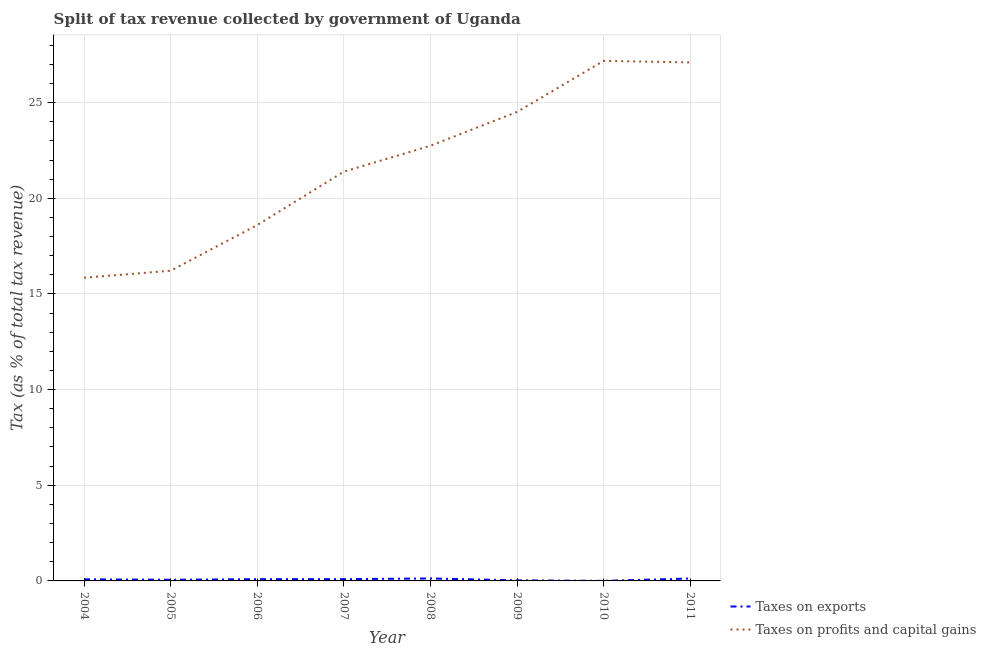How many different coloured lines are there?
Your answer should be very brief. 2. Is the number of lines equal to the number of legend labels?
Offer a very short reply. Yes. What is the percentage of revenue obtained from taxes on profits and capital gains in 2004?
Ensure brevity in your answer.  15.85. Across all years, what is the maximum percentage of revenue obtained from taxes on profits and capital gains?
Offer a terse response. 27.18. Across all years, what is the minimum percentage of revenue obtained from taxes on profits and capital gains?
Provide a short and direct response. 15.85. In which year was the percentage of revenue obtained from taxes on profits and capital gains minimum?
Offer a terse response. 2004. What is the total percentage of revenue obtained from taxes on exports in the graph?
Offer a very short reply. 0.62. What is the difference between the percentage of revenue obtained from taxes on exports in 2009 and that in 2011?
Your answer should be very brief. -0.09. What is the difference between the percentage of revenue obtained from taxes on profits and capital gains in 2008 and the percentage of revenue obtained from taxes on exports in 2007?
Ensure brevity in your answer.  22.65. What is the average percentage of revenue obtained from taxes on exports per year?
Your answer should be very brief. 0.08. In the year 2009, what is the difference between the percentage of revenue obtained from taxes on profits and capital gains and percentage of revenue obtained from taxes on exports?
Make the answer very short. 24.48. What is the ratio of the percentage of revenue obtained from taxes on profits and capital gains in 2004 to that in 2006?
Your response must be concise. 0.85. Is the percentage of revenue obtained from taxes on exports in 2008 less than that in 2010?
Make the answer very short. No. Is the difference between the percentage of revenue obtained from taxes on exports in 2006 and 2008 greater than the difference between the percentage of revenue obtained from taxes on profits and capital gains in 2006 and 2008?
Provide a short and direct response. Yes. What is the difference between the highest and the second highest percentage of revenue obtained from taxes on exports?
Your answer should be very brief. 0. What is the difference between the highest and the lowest percentage of revenue obtained from taxes on profits and capital gains?
Your response must be concise. 11.33. Is the sum of the percentage of revenue obtained from taxes on exports in 2005 and 2010 greater than the maximum percentage of revenue obtained from taxes on profits and capital gains across all years?
Your answer should be very brief. No. Is the percentage of revenue obtained from taxes on profits and capital gains strictly greater than the percentage of revenue obtained from taxes on exports over the years?
Provide a short and direct response. Yes. Is the percentage of revenue obtained from taxes on profits and capital gains strictly less than the percentage of revenue obtained from taxes on exports over the years?
Give a very brief answer. No. How many lines are there?
Provide a succinct answer. 2. Does the graph contain grids?
Your answer should be very brief. Yes. Where does the legend appear in the graph?
Keep it short and to the point. Bottom right. What is the title of the graph?
Ensure brevity in your answer.  Split of tax revenue collected by government of Uganda. Does "From production" appear as one of the legend labels in the graph?
Ensure brevity in your answer.  No. What is the label or title of the X-axis?
Your response must be concise. Year. What is the label or title of the Y-axis?
Offer a terse response. Tax (as % of total tax revenue). What is the Tax (as % of total tax revenue) of Taxes on exports in 2004?
Give a very brief answer. 0.08. What is the Tax (as % of total tax revenue) of Taxes on profits and capital gains in 2004?
Your answer should be compact. 15.85. What is the Tax (as % of total tax revenue) in Taxes on exports in 2005?
Ensure brevity in your answer.  0.06. What is the Tax (as % of total tax revenue) in Taxes on profits and capital gains in 2005?
Provide a succinct answer. 16.21. What is the Tax (as % of total tax revenue) of Taxes on exports in 2006?
Ensure brevity in your answer.  0.09. What is the Tax (as % of total tax revenue) in Taxes on profits and capital gains in 2006?
Ensure brevity in your answer.  18.6. What is the Tax (as % of total tax revenue) in Taxes on exports in 2007?
Your answer should be very brief. 0.09. What is the Tax (as % of total tax revenue) of Taxes on profits and capital gains in 2007?
Ensure brevity in your answer.  21.39. What is the Tax (as % of total tax revenue) in Taxes on exports in 2008?
Offer a very short reply. 0.13. What is the Tax (as % of total tax revenue) of Taxes on profits and capital gains in 2008?
Offer a very short reply. 22.74. What is the Tax (as % of total tax revenue) in Taxes on exports in 2009?
Your answer should be very brief. 0.03. What is the Tax (as % of total tax revenue) of Taxes on profits and capital gains in 2009?
Ensure brevity in your answer.  24.51. What is the Tax (as % of total tax revenue) of Taxes on exports in 2010?
Give a very brief answer. 0. What is the Tax (as % of total tax revenue) of Taxes on profits and capital gains in 2010?
Keep it short and to the point. 27.18. What is the Tax (as % of total tax revenue) of Taxes on exports in 2011?
Give a very brief answer. 0.13. What is the Tax (as % of total tax revenue) in Taxes on profits and capital gains in 2011?
Provide a short and direct response. 27.1. Across all years, what is the maximum Tax (as % of total tax revenue) in Taxes on exports?
Your answer should be compact. 0.13. Across all years, what is the maximum Tax (as % of total tax revenue) in Taxes on profits and capital gains?
Give a very brief answer. 27.18. Across all years, what is the minimum Tax (as % of total tax revenue) of Taxes on exports?
Provide a succinct answer. 0. Across all years, what is the minimum Tax (as % of total tax revenue) in Taxes on profits and capital gains?
Make the answer very short. 15.85. What is the total Tax (as % of total tax revenue) of Taxes on exports in the graph?
Provide a short and direct response. 0.62. What is the total Tax (as % of total tax revenue) in Taxes on profits and capital gains in the graph?
Your response must be concise. 173.59. What is the difference between the Tax (as % of total tax revenue) in Taxes on exports in 2004 and that in 2005?
Provide a short and direct response. 0.02. What is the difference between the Tax (as % of total tax revenue) in Taxes on profits and capital gains in 2004 and that in 2005?
Offer a very short reply. -0.36. What is the difference between the Tax (as % of total tax revenue) in Taxes on exports in 2004 and that in 2006?
Offer a terse response. -0.01. What is the difference between the Tax (as % of total tax revenue) of Taxes on profits and capital gains in 2004 and that in 2006?
Provide a succinct answer. -2.75. What is the difference between the Tax (as % of total tax revenue) in Taxes on exports in 2004 and that in 2007?
Your answer should be very brief. -0.01. What is the difference between the Tax (as % of total tax revenue) in Taxes on profits and capital gains in 2004 and that in 2007?
Provide a succinct answer. -5.54. What is the difference between the Tax (as % of total tax revenue) in Taxes on exports in 2004 and that in 2008?
Offer a terse response. -0.04. What is the difference between the Tax (as % of total tax revenue) of Taxes on profits and capital gains in 2004 and that in 2008?
Provide a short and direct response. -6.9. What is the difference between the Tax (as % of total tax revenue) of Taxes on exports in 2004 and that in 2009?
Make the answer very short. 0.05. What is the difference between the Tax (as % of total tax revenue) in Taxes on profits and capital gains in 2004 and that in 2009?
Provide a succinct answer. -8.66. What is the difference between the Tax (as % of total tax revenue) in Taxes on exports in 2004 and that in 2010?
Provide a short and direct response. 0.08. What is the difference between the Tax (as % of total tax revenue) in Taxes on profits and capital gains in 2004 and that in 2010?
Provide a short and direct response. -11.33. What is the difference between the Tax (as % of total tax revenue) of Taxes on exports in 2004 and that in 2011?
Provide a short and direct response. -0.04. What is the difference between the Tax (as % of total tax revenue) of Taxes on profits and capital gains in 2004 and that in 2011?
Provide a succinct answer. -11.25. What is the difference between the Tax (as % of total tax revenue) of Taxes on exports in 2005 and that in 2006?
Your answer should be compact. -0.03. What is the difference between the Tax (as % of total tax revenue) of Taxes on profits and capital gains in 2005 and that in 2006?
Your response must be concise. -2.39. What is the difference between the Tax (as % of total tax revenue) in Taxes on exports in 2005 and that in 2007?
Provide a succinct answer. -0.03. What is the difference between the Tax (as % of total tax revenue) of Taxes on profits and capital gains in 2005 and that in 2007?
Your answer should be very brief. -5.18. What is the difference between the Tax (as % of total tax revenue) in Taxes on exports in 2005 and that in 2008?
Keep it short and to the point. -0.07. What is the difference between the Tax (as % of total tax revenue) of Taxes on profits and capital gains in 2005 and that in 2008?
Give a very brief answer. -6.53. What is the difference between the Tax (as % of total tax revenue) in Taxes on exports in 2005 and that in 2009?
Ensure brevity in your answer.  0.03. What is the difference between the Tax (as % of total tax revenue) in Taxes on profits and capital gains in 2005 and that in 2009?
Your response must be concise. -8.3. What is the difference between the Tax (as % of total tax revenue) in Taxes on exports in 2005 and that in 2010?
Offer a terse response. 0.06. What is the difference between the Tax (as % of total tax revenue) of Taxes on profits and capital gains in 2005 and that in 2010?
Your answer should be very brief. -10.97. What is the difference between the Tax (as % of total tax revenue) in Taxes on exports in 2005 and that in 2011?
Your answer should be compact. -0.07. What is the difference between the Tax (as % of total tax revenue) of Taxes on profits and capital gains in 2005 and that in 2011?
Your answer should be very brief. -10.89. What is the difference between the Tax (as % of total tax revenue) of Taxes on exports in 2006 and that in 2007?
Offer a terse response. -0. What is the difference between the Tax (as % of total tax revenue) in Taxes on profits and capital gains in 2006 and that in 2007?
Ensure brevity in your answer.  -2.79. What is the difference between the Tax (as % of total tax revenue) in Taxes on exports in 2006 and that in 2008?
Offer a very short reply. -0.04. What is the difference between the Tax (as % of total tax revenue) of Taxes on profits and capital gains in 2006 and that in 2008?
Provide a short and direct response. -4.14. What is the difference between the Tax (as % of total tax revenue) in Taxes on exports in 2006 and that in 2009?
Your answer should be very brief. 0.06. What is the difference between the Tax (as % of total tax revenue) of Taxes on profits and capital gains in 2006 and that in 2009?
Keep it short and to the point. -5.91. What is the difference between the Tax (as % of total tax revenue) of Taxes on exports in 2006 and that in 2010?
Your answer should be compact. 0.09. What is the difference between the Tax (as % of total tax revenue) of Taxes on profits and capital gains in 2006 and that in 2010?
Offer a terse response. -8.58. What is the difference between the Tax (as % of total tax revenue) of Taxes on exports in 2006 and that in 2011?
Offer a very short reply. -0.03. What is the difference between the Tax (as % of total tax revenue) in Taxes on profits and capital gains in 2006 and that in 2011?
Provide a succinct answer. -8.5. What is the difference between the Tax (as % of total tax revenue) of Taxes on exports in 2007 and that in 2008?
Your answer should be compact. -0.04. What is the difference between the Tax (as % of total tax revenue) in Taxes on profits and capital gains in 2007 and that in 2008?
Offer a terse response. -1.35. What is the difference between the Tax (as % of total tax revenue) of Taxes on exports in 2007 and that in 2009?
Give a very brief answer. 0.06. What is the difference between the Tax (as % of total tax revenue) of Taxes on profits and capital gains in 2007 and that in 2009?
Your answer should be very brief. -3.12. What is the difference between the Tax (as % of total tax revenue) in Taxes on exports in 2007 and that in 2010?
Your response must be concise. 0.09. What is the difference between the Tax (as % of total tax revenue) in Taxes on profits and capital gains in 2007 and that in 2010?
Make the answer very short. -5.79. What is the difference between the Tax (as % of total tax revenue) of Taxes on exports in 2007 and that in 2011?
Provide a short and direct response. -0.03. What is the difference between the Tax (as % of total tax revenue) of Taxes on profits and capital gains in 2007 and that in 2011?
Your answer should be compact. -5.71. What is the difference between the Tax (as % of total tax revenue) in Taxes on exports in 2008 and that in 2009?
Keep it short and to the point. 0.1. What is the difference between the Tax (as % of total tax revenue) in Taxes on profits and capital gains in 2008 and that in 2009?
Make the answer very short. -1.77. What is the difference between the Tax (as % of total tax revenue) of Taxes on exports in 2008 and that in 2010?
Keep it short and to the point. 0.13. What is the difference between the Tax (as % of total tax revenue) in Taxes on profits and capital gains in 2008 and that in 2010?
Make the answer very short. -4.44. What is the difference between the Tax (as % of total tax revenue) of Taxes on exports in 2008 and that in 2011?
Offer a terse response. 0. What is the difference between the Tax (as % of total tax revenue) of Taxes on profits and capital gains in 2008 and that in 2011?
Offer a very short reply. -4.36. What is the difference between the Tax (as % of total tax revenue) of Taxes on exports in 2009 and that in 2010?
Make the answer very short. 0.03. What is the difference between the Tax (as % of total tax revenue) in Taxes on profits and capital gains in 2009 and that in 2010?
Make the answer very short. -2.67. What is the difference between the Tax (as % of total tax revenue) of Taxes on exports in 2009 and that in 2011?
Offer a terse response. -0.09. What is the difference between the Tax (as % of total tax revenue) of Taxes on profits and capital gains in 2009 and that in 2011?
Give a very brief answer. -2.59. What is the difference between the Tax (as % of total tax revenue) in Taxes on exports in 2010 and that in 2011?
Provide a succinct answer. -0.12. What is the difference between the Tax (as % of total tax revenue) of Taxes on profits and capital gains in 2010 and that in 2011?
Give a very brief answer. 0.08. What is the difference between the Tax (as % of total tax revenue) in Taxes on exports in 2004 and the Tax (as % of total tax revenue) in Taxes on profits and capital gains in 2005?
Your answer should be very brief. -16.13. What is the difference between the Tax (as % of total tax revenue) of Taxes on exports in 2004 and the Tax (as % of total tax revenue) of Taxes on profits and capital gains in 2006?
Your response must be concise. -18.52. What is the difference between the Tax (as % of total tax revenue) of Taxes on exports in 2004 and the Tax (as % of total tax revenue) of Taxes on profits and capital gains in 2007?
Give a very brief answer. -21.31. What is the difference between the Tax (as % of total tax revenue) in Taxes on exports in 2004 and the Tax (as % of total tax revenue) in Taxes on profits and capital gains in 2008?
Make the answer very short. -22.66. What is the difference between the Tax (as % of total tax revenue) of Taxes on exports in 2004 and the Tax (as % of total tax revenue) of Taxes on profits and capital gains in 2009?
Provide a succinct answer. -24.43. What is the difference between the Tax (as % of total tax revenue) in Taxes on exports in 2004 and the Tax (as % of total tax revenue) in Taxes on profits and capital gains in 2010?
Provide a succinct answer. -27.1. What is the difference between the Tax (as % of total tax revenue) of Taxes on exports in 2004 and the Tax (as % of total tax revenue) of Taxes on profits and capital gains in 2011?
Offer a terse response. -27.02. What is the difference between the Tax (as % of total tax revenue) of Taxes on exports in 2005 and the Tax (as % of total tax revenue) of Taxes on profits and capital gains in 2006?
Your answer should be very brief. -18.54. What is the difference between the Tax (as % of total tax revenue) in Taxes on exports in 2005 and the Tax (as % of total tax revenue) in Taxes on profits and capital gains in 2007?
Your answer should be compact. -21.33. What is the difference between the Tax (as % of total tax revenue) in Taxes on exports in 2005 and the Tax (as % of total tax revenue) in Taxes on profits and capital gains in 2008?
Provide a succinct answer. -22.68. What is the difference between the Tax (as % of total tax revenue) in Taxes on exports in 2005 and the Tax (as % of total tax revenue) in Taxes on profits and capital gains in 2009?
Your answer should be compact. -24.45. What is the difference between the Tax (as % of total tax revenue) in Taxes on exports in 2005 and the Tax (as % of total tax revenue) in Taxes on profits and capital gains in 2010?
Give a very brief answer. -27.12. What is the difference between the Tax (as % of total tax revenue) of Taxes on exports in 2005 and the Tax (as % of total tax revenue) of Taxes on profits and capital gains in 2011?
Give a very brief answer. -27.04. What is the difference between the Tax (as % of total tax revenue) in Taxes on exports in 2006 and the Tax (as % of total tax revenue) in Taxes on profits and capital gains in 2007?
Make the answer very short. -21.3. What is the difference between the Tax (as % of total tax revenue) in Taxes on exports in 2006 and the Tax (as % of total tax revenue) in Taxes on profits and capital gains in 2008?
Provide a succinct answer. -22.65. What is the difference between the Tax (as % of total tax revenue) of Taxes on exports in 2006 and the Tax (as % of total tax revenue) of Taxes on profits and capital gains in 2009?
Offer a very short reply. -24.42. What is the difference between the Tax (as % of total tax revenue) of Taxes on exports in 2006 and the Tax (as % of total tax revenue) of Taxes on profits and capital gains in 2010?
Offer a terse response. -27.09. What is the difference between the Tax (as % of total tax revenue) in Taxes on exports in 2006 and the Tax (as % of total tax revenue) in Taxes on profits and capital gains in 2011?
Give a very brief answer. -27.01. What is the difference between the Tax (as % of total tax revenue) in Taxes on exports in 2007 and the Tax (as % of total tax revenue) in Taxes on profits and capital gains in 2008?
Make the answer very short. -22.65. What is the difference between the Tax (as % of total tax revenue) in Taxes on exports in 2007 and the Tax (as % of total tax revenue) in Taxes on profits and capital gains in 2009?
Ensure brevity in your answer.  -24.42. What is the difference between the Tax (as % of total tax revenue) of Taxes on exports in 2007 and the Tax (as % of total tax revenue) of Taxes on profits and capital gains in 2010?
Your answer should be compact. -27.09. What is the difference between the Tax (as % of total tax revenue) of Taxes on exports in 2007 and the Tax (as % of total tax revenue) of Taxes on profits and capital gains in 2011?
Keep it short and to the point. -27.01. What is the difference between the Tax (as % of total tax revenue) of Taxes on exports in 2008 and the Tax (as % of total tax revenue) of Taxes on profits and capital gains in 2009?
Provide a short and direct response. -24.38. What is the difference between the Tax (as % of total tax revenue) in Taxes on exports in 2008 and the Tax (as % of total tax revenue) in Taxes on profits and capital gains in 2010?
Give a very brief answer. -27.05. What is the difference between the Tax (as % of total tax revenue) in Taxes on exports in 2008 and the Tax (as % of total tax revenue) in Taxes on profits and capital gains in 2011?
Make the answer very short. -26.97. What is the difference between the Tax (as % of total tax revenue) in Taxes on exports in 2009 and the Tax (as % of total tax revenue) in Taxes on profits and capital gains in 2010?
Your answer should be very brief. -27.15. What is the difference between the Tax (as % of total tax revenue) of Taxes on exports in 2009 and the Tax (as % of total tax revenue) of Taxes on profits and capital gains in 2011?
Offer a very short reply. -27.07. What is the difference between the Tax (as % of total tax revenue) in Taxes on exports in 2010 and the Tax (as % of total tax revenue) in Taxes on profits and capital gains in 2011?
Ensure brevity in your answer.  -27.1. What is the average Tax (as % of total tax revenue) of Taxes on exports per year?
Make the answer very short. 0.08. What is the average Tax (as % of total tax revenue) of Taxes on profits and capital gains per year?
Make the answer very short. 21.7. In the year 2004, what is the difference between the Tax (as % of total tax revenue) of Taxes on exports and Tax (as % of total tax revenue) of Taxes on profits and capital gains?
Keep it short and to the point. -15.76. In the year 2005, what is the difference between the Tax (as % of total tax revenue) of Taxes on exports and Tax (as % of total tax revenue) of Taxes on profits and capital gains?
Your answer should be very brief. -16.15. In the year 2006, what is the difference between the Tax (as % of total tax revenue) of Taxes on exports and Tax (as % of total tax revenue) of Taxes on profits and capital gains?
Offer a very short reply. -18.51. In the year 2007, what is the difference between the Tax (as % of total tax revenue) of Taxes on exports and Tax (as % of total tax revenue) of Taxes on profits and capital gains?
Offer a terse response. -21.3. In the year 2008, what is the difference between the Tax (as % of total tax revenue) of Taxes on exports and Tax (as % of total tax revenue) of Taxes on profits and capital gains?
Your response must be concise. -22.62. In the year 2009, what is the difference between the Tax (as % of total tax revenue) of Taxes on exports and Tax (as % of total tax revenue) of Taxes on profits and capital gains?
Your answer should be compact. -24.48. In the year 2010, what is the difference between the Tax (as % of total tax revenue) in Taxes on exports and Tax (as % of total tax revenue) in Taxes on profits and capital gains?
Your answer should be very brief. -27.18. In the year 2011, what is the difference between the Tax (as % of total tax revenue) in Taxes on exports and Tax (as % of total tax revenue) in Taxes on profits and capital gains?
Your answer should be very brief. -26.97. What is the ratio of the Tax (as % of total tax revenue) of Taxes on exports in 2004 to that in 2005?
Provide a succinct answer. 1.4. What is the ratio of the Tax (as % of total tax revenue) in Taxes on profits and capital gains in 2004 to that in 2005?
Keep it short and to the point. 0.98. What is the ratio of the Tax (as % of total tax revenue) in Taxes on exports in 2004 to that in 2006?
Your response must be concise. 0.93. What is the ratio of the Tax (as % of total tax revenue) in Taxes on profits and capital gains in 2004 to that in 2006?
Make the answer very short. 0.85. What is the ratio of the Tax (as % of total tax revenue) of Taxes on exports in 2004 to that in 2007?
Keep it short and to the point. 0.91. What is the ratio of the Tax (as % of total tax revenue) in Taxes on profits and capital gains in 2004 to that in 2007?
Keep it short and to the point. 0.74. What is the ratio of the Tax (as % of total tax revenue) in Taxes on exports in 2004 to that in 2008?
Your response must be concise. 0.66. What is the ratio of the Tax (as % of total tax revenue) of Taxes on profits and capital gains in 2004 to that in 2008?
Your answer should be very brief. 0.7. What is the ratio of the Tax (as % of total tax revenue) of Taxes on exports in 2004 to that in 2009?
Offer a very short reply. 2.73. What is the ratio of the Tax (as % of total tax revenue) of Taxes on profits and capital gains in 2004 to that in 2009?
Give a very brief answer. 0.65. What is the ratio of the Tax (as % of total tax revenue) of Taxes on exports in 2004 to that in 2010?
Ensure brevity in your answer.  29.24. What is the ratio of the Tax (as % of total tax revenue) of Taxes on profits and capital gains in 2004 to that in 2010?
Give a very brief answer. 0.58. What is the ratio of the Tax (as % of total tax revenue) in Taxes on exports in 2004 to that in 2011?
Make the answer very short. 0.67. What is the ratio of the Tax (as % of total tax revenue) of Taxes on profits and capital gains in 2004 to that in 2011?
Provide a succinct answer. 0.58. What is the ratio of the Tax (as % of total tax revenue) of Taxes on exports in 2005 to that in 2006?
Your response must be concise. 0.66. What is the ratio of the Tax (as % of total tax revenue) in Taxes on profits and capital gains in 2005 to that in 2006?
Your response must be concise. 0.87. What is the ratio of the Tax (as % of total tax revenue) in Taxes on exports in 2005 to that in 2007?
Keep it short and to the point. 0.65. What is the ratio of the Tax (as % of total tax revenue) in Taxes on profits and capital gains in 2005 to that in 2007?
Provide a short and direct response. 0.76. What is the ratio of the Tax (as % of total tax revenue) of Taxes on exports in 2005 to that in 2008?
Give a very brief answer. 0.47. What is the ratio of the Tax (as % of total tax revenue) of Taxes on profits and capital gains in 2005 to that in 2008?
Give a very brief answer. 0.71. What is the ratio of the Tax (as % of total tax revenue) in Taxes on exports in 2005 to that in 2009?
Offer a terse response. 1.94. What is the ratio of the Tax (as % of total tax revenue) in Taxes on profits and capital gains in 2005 to that in 2009?
Provide a succinct answer. 0.66. What is the ratio of the Tax (as % of total tax revenue) of Taxes on exports in 2005 to that in 2010?
Keep it short and to the point. 20.84. What is the ratio of the Tax (as % of total tax revenue) of Taxes on profits and capital gains in 2005 to that in 2010?
Offer a very short reply. 0.6. What is the ratio of the Tax (as % of total tax revenue) of Taxes on exports in 2005 to that in 2011?
Ensure brevity in your answer.  0.48. What is the ratio of the Tax (as % of total tax revenue) in Taxes on profits and capital gains in 2005 to that in 2011?
Make the answer very short. 0.6. What is the ratio of the Tax (as % of total tax revenue) of Taxes on exports in 2006 to that in 2007?
Give a very brief answer. 0.99. What is the ratio of the Tax (as % of total tax revenue) in Taxes on profits and capital gains in 2006 to that in 2007?
Give a very brief answer. 0.87. What is the ratio of the Tax (as % of total tax revenue) in Taxes on exports in 2006 to that in 2008?
Your response must be concise. 0.71. What is the ratio of the Tax (as % of total tax revenue) of Taxes on profits and capital gains in 2006 to that in 2008?
Your response must be concise. 0.82. What is the ratio of the Tax (as % of total tax revenue) in Taxes on exports in 2006 to that in 2009?
Give a very brief answer. 2.94. What is the ratio of the Tax (as % of total tax revenue) in Taxes on profits and capital gains in 2006 to that in 2009?
Your answer should be very brief. 0.76. What is the ratio of the Tax (as % of total tax revenue) in Taxes on exports in 2006 to that in 2010?
Your response must be concise. 31.54. What is the ratio of the Tax (as % of total tax revenue) of Taxes on profits and capital gains in 2006 to that in 2010?
Provide a succinct answer. 0.68. What is the ratio of the Tax (as % of total tax revenue) of Taxes on exports in 2006 to that in 2011?
Ensure brevity in your answer.  0.73. What is the ratio of the Tax (as % of total tax revenue) in Taxes on profits and capital gains in 2006 to that in 2011?
Your answer should be compact. 0.69. What is the ratio of the Tax (as % of total tax revenue) of Taxes on exports in 2007 to that in 2008?
Make the answer very short. 0.72. What is the ratio of the Tax (as % of total tax revenue) in Taxes on profits and capital gains in 2007 to that in 2008?
Ensure brevity in your answer.  0.94. What is the ratio of the Tax (as % of total tax revenue) in Taxes on exports in 2007 to that in 2009?
Make the answer very short. 2.98. What is the ratio of the Tax (as % of total tax revenue) in Taxes on profits and capital gains in 2007 to that in 2009?
Your answer should be very brief. 0.87. What is the ratio of the Tax (as % of total tax revenue) of Taxes on exports in 2007 to that in 2010?
Your answer should be compact. 31.99. What is the ratio of the Tax (as % of total tax revenue) in Taxes on profits and capital gains in 2007 to that in 2010?
Ensure brevity in your answer.  0.79. What is the ratio of the Tax (as % of total tax revenue) of Taxes on exports in 2007 to that in 2011?
Ensure brevity in your answer.  0.74. What is the ratio of the Tax (as % of total tax revenue) in Taxes on profits and capital gains in 2007 to that in 2011?
Make the answer very short. 0.79. What is the ratio of the Tax (as % of total tax revenue) of Taxes on exports in 2008 to that in 2009?
Keep it short and to the point. 4.15. What is the ratio of the Tax (as % of total tax revenue) in Taxes on profits and capital gains in 2008 to that in 2009?
Offer a terse response. 0.93. What is the ratio of the Tax (as % of total tax revenue) in Taxes on exports in 2008 to that in 2010?
Your answer should be very brief. 44.5. What is the ratio of the Tax (as % of total tax revenue) in Taxes on profits and capital gains in 2008 to that in 2010?
Your answer should be very brief. 0.84. What is the ratio of the Tax (as % of total tax revenue) of Taxes on exports in 2008 to that in 2011?
Give a very brief answer. 1.02. What is the ratio of the Tax (as % of total tax revenue) of Taxes on profits and capital gains in 2008 to that in 2011?
Keep it short and to the point. 0.84. What is the ratio of the Tax (as % of total tax revenue) in Taxes on exports in 2009 to that in 2010?
Provide a short and direct response. 10.72. What is the ratio of the Tax (as % of total tax revenue) of Taxes on profits and capital gains in 2009 to that in 2010?
Offer a very short reply. 0.9. What is the ratio of the Tax (as % of total tax revenue) of Taxes on exports in 2009 to that in 2011?
Your answer should be very brief. 0.25. What is the ratio of the Tax (as % of total tax revenue) in Taxes on profits and capital gains in 2009 to that in 2011?
Give a very brief answer. 0.9. What is the ratio of the Tax (as % of total tax revenue) in Taxes on exports in 2010 to that in 2011?
Offer a terse response. 0.02. What is the ratio of the Tax (as % of total tax revenue) in Taxes on profits and capital gains in 2010 to that in 2011?
Provide a succinct answer. 1. What is the difference between the highest and the second highest Tax (as % of total tax revenue) in Taxes on exports?
Provide a short and direct response. 0. What is the difference between the highest and the second highest Tax (as % of total tax revenue) in Taxes on profits and capital gains?
Ensure brevity in your answer.  0.08. What is the difference between the highest and the lowest Tax (as % of total tax revenue) of Taxes on exports?
Provide a short and direct response. 0.13. What is the difference between the highest and the lowest Tax (as % of total tax revenue) of Taxes on profits and capital gains?
Offer a very short reply. 11.33. 